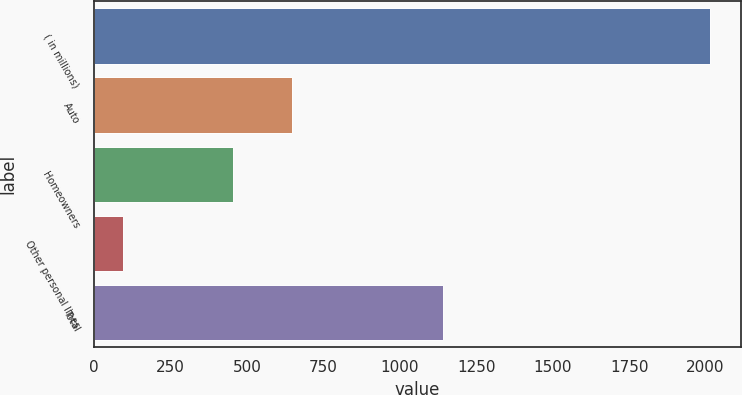Convert chart. <chart><loc_0><loc_0><loc_500><loc_500><bar_chart><fcel>( in millions)<fcel>Auto<fcel>Homeowners<fcel>Other personal lines<fcel>Total<nl><fcel>2016<fcel>646.1<fcel>454<fcel>95<fcel>1140<nl></chart> 